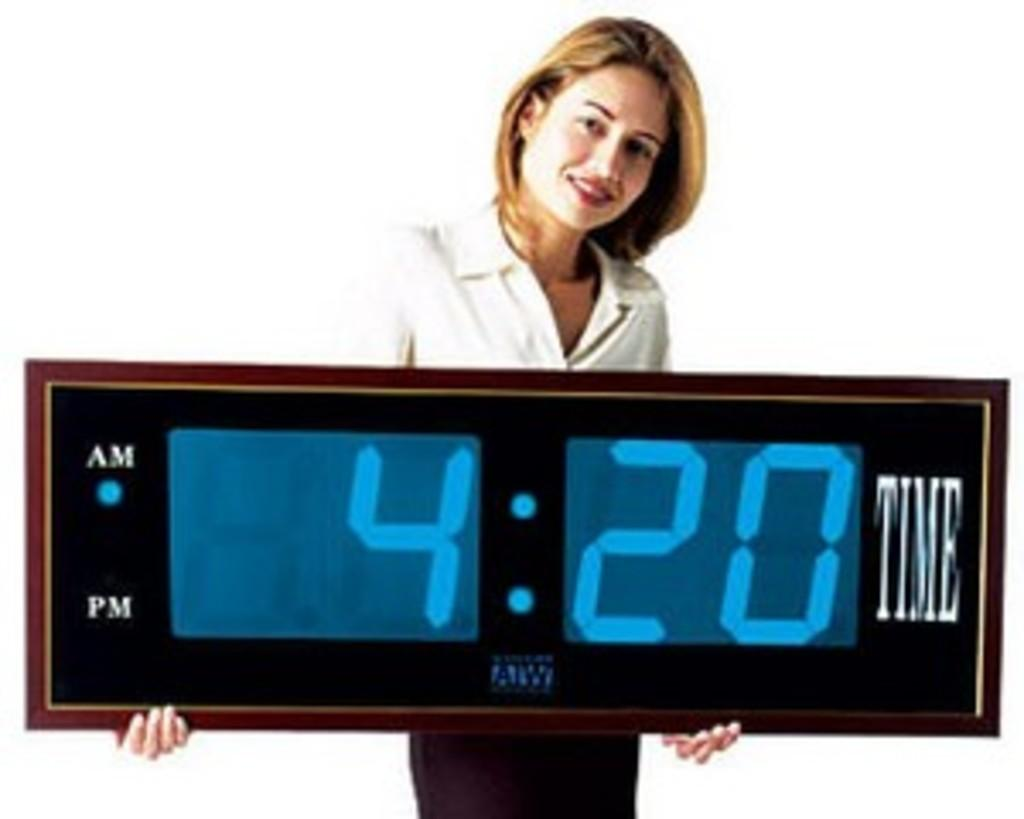<image>
Write a terse but informative summary of the picture. A woman holds a huge clock saying the time is 4:20. 